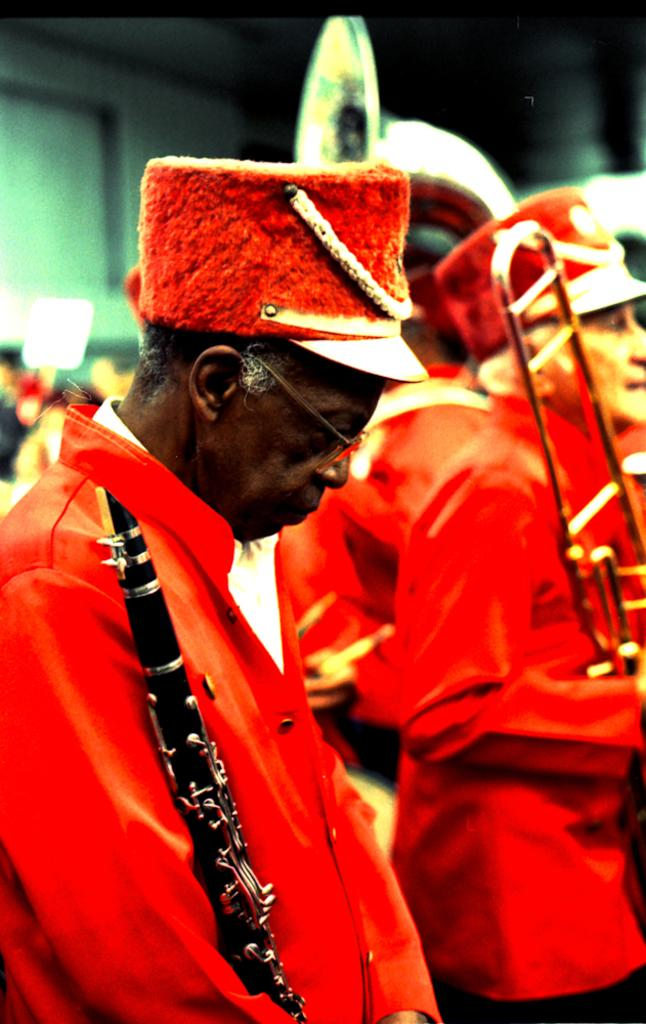What are the persons in the image wearing? The persons in the image are wearing orange colored dresses. What are the persons doing in the image? The persons are standing and holding musical instruments in their hands. Can you describe the background of the image? The background of the image is blurry. What type of mine can be seen in the background of the image? There is no mine present in the image; the background is blurry. 